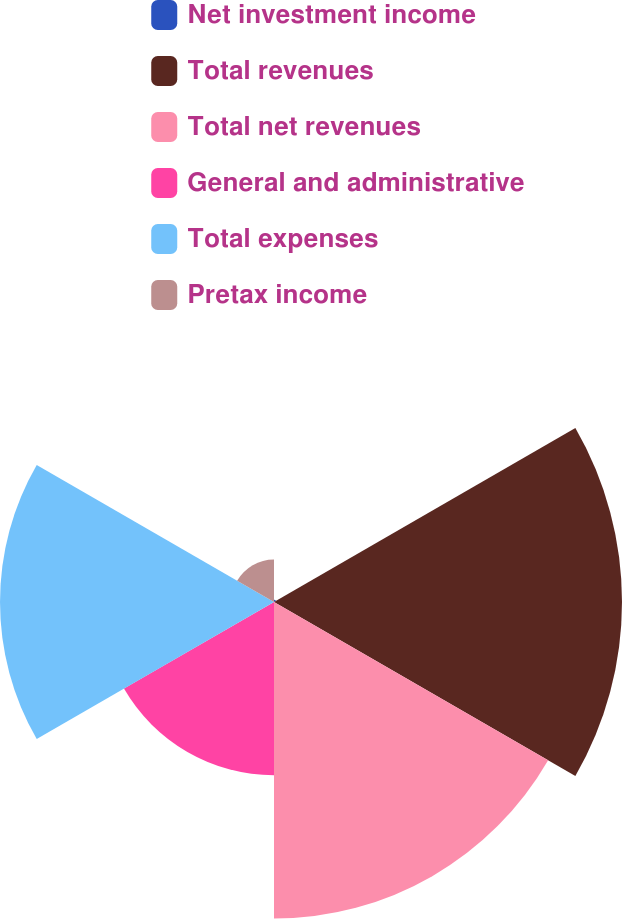Convert chart. <chart><loc_0><loc_0><loc_500><loc_500><pie_chart><fcel>Net investment income<fcel>Total revenues<fcel>Total net revenues<fcel>General and administrative<fcel>Total expenses<fcel>Pretax income<nl><fcel>0.2%<fcel>30.09%<fcel>27.37%<fcel>14.98%<fcel>23.69%<fcel>3.68%<nl></chart> 